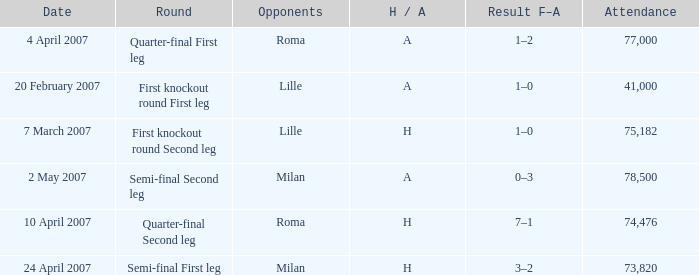Which round has Attendance larger than 41,000, a H/A of A, and a Result F–A of 1–2? Quarter-final First leg. 